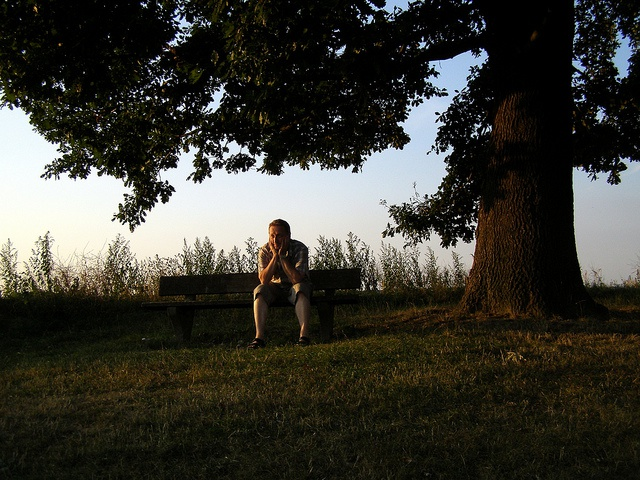Describe the objects in this image and their specific colors. I can see bench in black and gray tones and people in black, maroon, and tan tones in this image. 